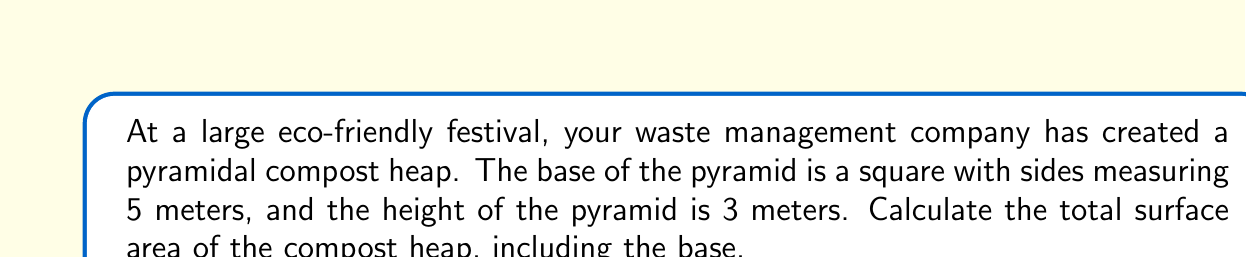Teach me how to tackle this problem. To solve this problem, we need to follow these steps:

1. Calculate the area of the square base
2. Find the slant height of the pyramid
3. Calculate the area of one triangular face
4. Determine the total surface area

Step 1: Area of the square base
The area of a square is given by the formula $A = s^2$, where $s$ is the side length.
$$A_{base} = 5^2 = 25 \text{ m}^2$$

Step 2: Slant height of the pyramid
The slant height ($l$) can be found using the Pythagorean theorem. We need to consider a right triangle formed by half the base diagonal, the height, and the slant height.

Half of the base diagonal: $\frac{5\sqrt{2}}{2}$

Using the Pythagorean theorem:
$$l^2 = (\frac{5\sqrt{2}}{2})^2 + 3^2$$
$$l^2 = \frac{50}{4} + 9 = \frac{25}{2} + 9 = \frac{25}{2} + \frac{18}{2} = \frac{43}{2}$$
$$l = \sqrt{\frac{43}{2}} \approx 4.64 \text{ m}$$

Step 3: Area of one triangular face
The area of a triangle is given by $A = \frac{1}{2} \times base \times height$
$$A_{face} = \frac{1}{2} \times 5 \times 4.64 = 11.6 \text{ m}^2$$

Step 4: Total surface area
The total surface area is the sum of the base area and the areas of the four triangular faces.
$$SA_{total} = A_{base} + 4 \times A_{face}$$
$$SA_{total} = 25 + 4 \times 11.6 = 25 + 46.4 = 71.4 \text{ m}^2$$

[asy]
import geometry;

size(200);

pair A = (0,0), B = (5,0), C = (5,5), D = (0,5), E = (2.5,3);

draw(A--B--C--D--cycle);
draw(A--E);
draw(B--E);
draw(C--E);
draw(D--E);

label("5 m", (A+B)/2, S);
label("5 m", (B+C)/2, E);
label("3 m", (2.5,0)--E, W);

dot("A", A, SW);
dot("B", B, SE);
dot("C", C, NE);
dot("D", D, NW);
dot("E", E, N);
[/asy]
Answer: The total surface area of the pyramidal compost heap is approximately $71.4 \text{ m}^2$. 